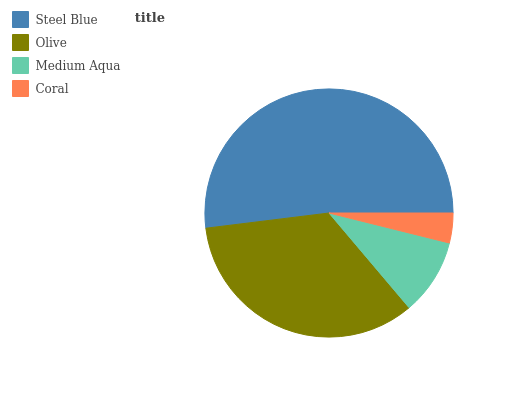Is Coral the minimum?
Answer yes or no. Yes. Is Steel Blue the maximum?
Answer yes or no. Yes. Is Olive the minimum?
Answer yes or no. No. Is Olive the maximum?
Answer yes or no. No. Is Steel Blue greater than Olive?
Answer yes or no. Yes. Is Olive less than Steel Blue?
Answer yes or no. Yes. Is Olive greater than Steel Blue?
Answer yes or no. No. Is Steel Blue less than Olive?
Answer yes or no. No. Is Olive the high median?
Answer yes or no. Yes. Is Medium Aqua the low median?
Answer yes or no. Yes. Is Coral the high median?
Answer yes or no. No. Is Olive the low median?
Answer yes or no. No. 